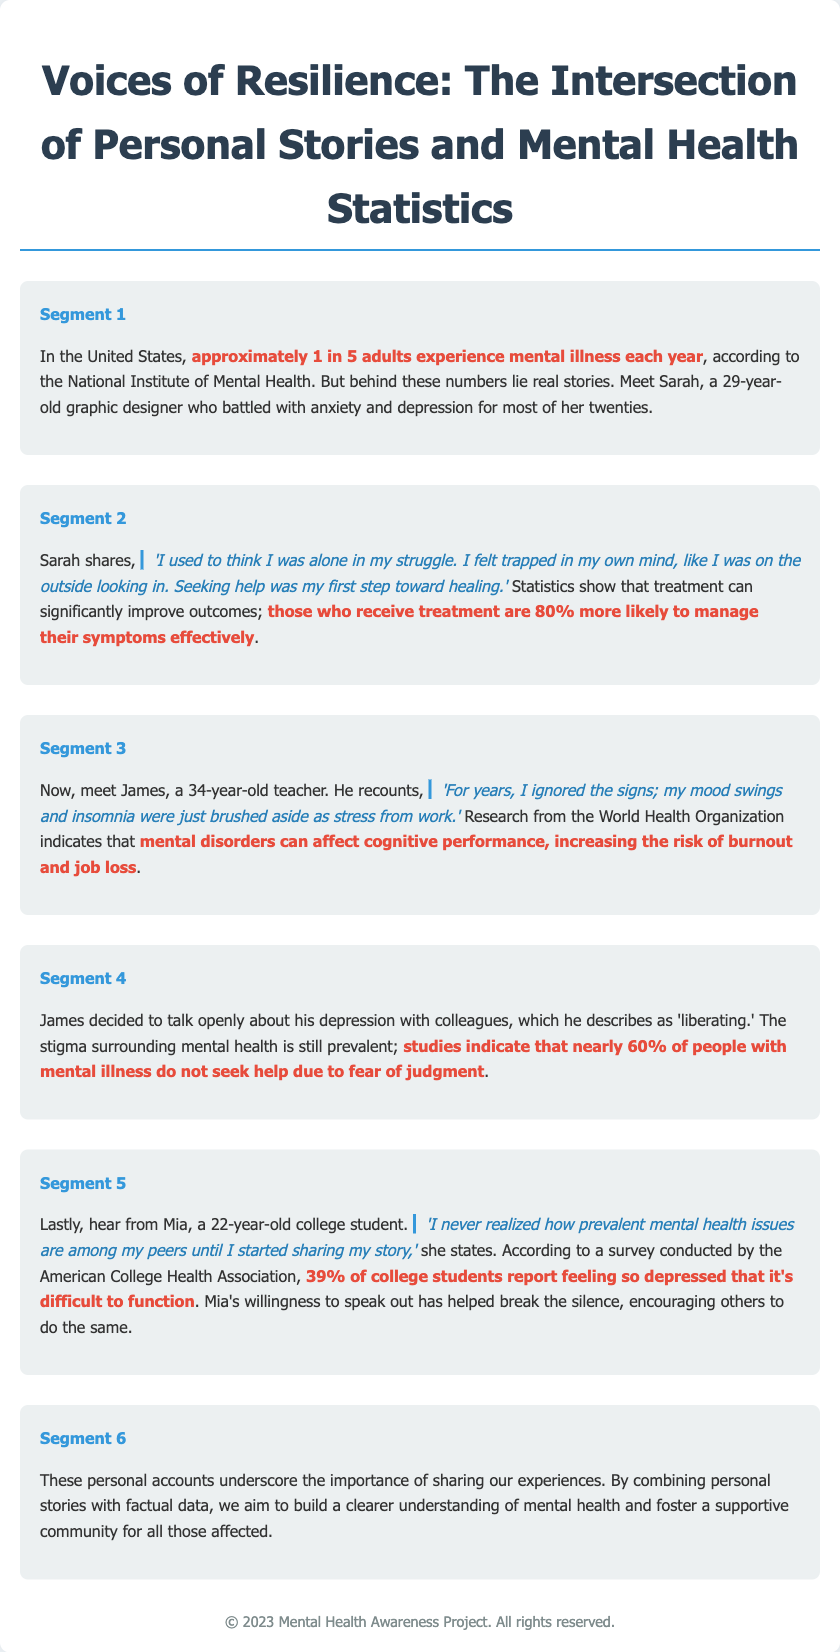What is the title of the project? The title is mentioned prominently at the beginning of the document, which is "Voices of Resilience: The Intersection of Personal Stories and Mental Health Statistics."
Answer: Voices of Resilience: The Intersection of Personal Stories and Mental Health Statistics How many segments are there in the document? The document contains multiple segments that narrate personal stories, with each segment labeled numerically. There are six segments in total.
Answer: 6 What percentage of college students report feeling depressed? A specific survey statistic is provided in the document stating the percentage of college students who feel depressed.
Answer: 39% Who shares their story about feeling trapped in their own mind? The document features personal stories, and it's stated that Sarah battled with anxiety and depression.
Answer: Sarah What is the statistic related to treatment effectiveness? The document states a statistic on how much treatment can improve outcomes for those managing symptoms.
Answer: 80% What issue does James discuss in his segment? James mentions a personal experience that relates to mental health issues at work, specifically mood swings and insomnia.
Answer: Mood swings and insomnia 